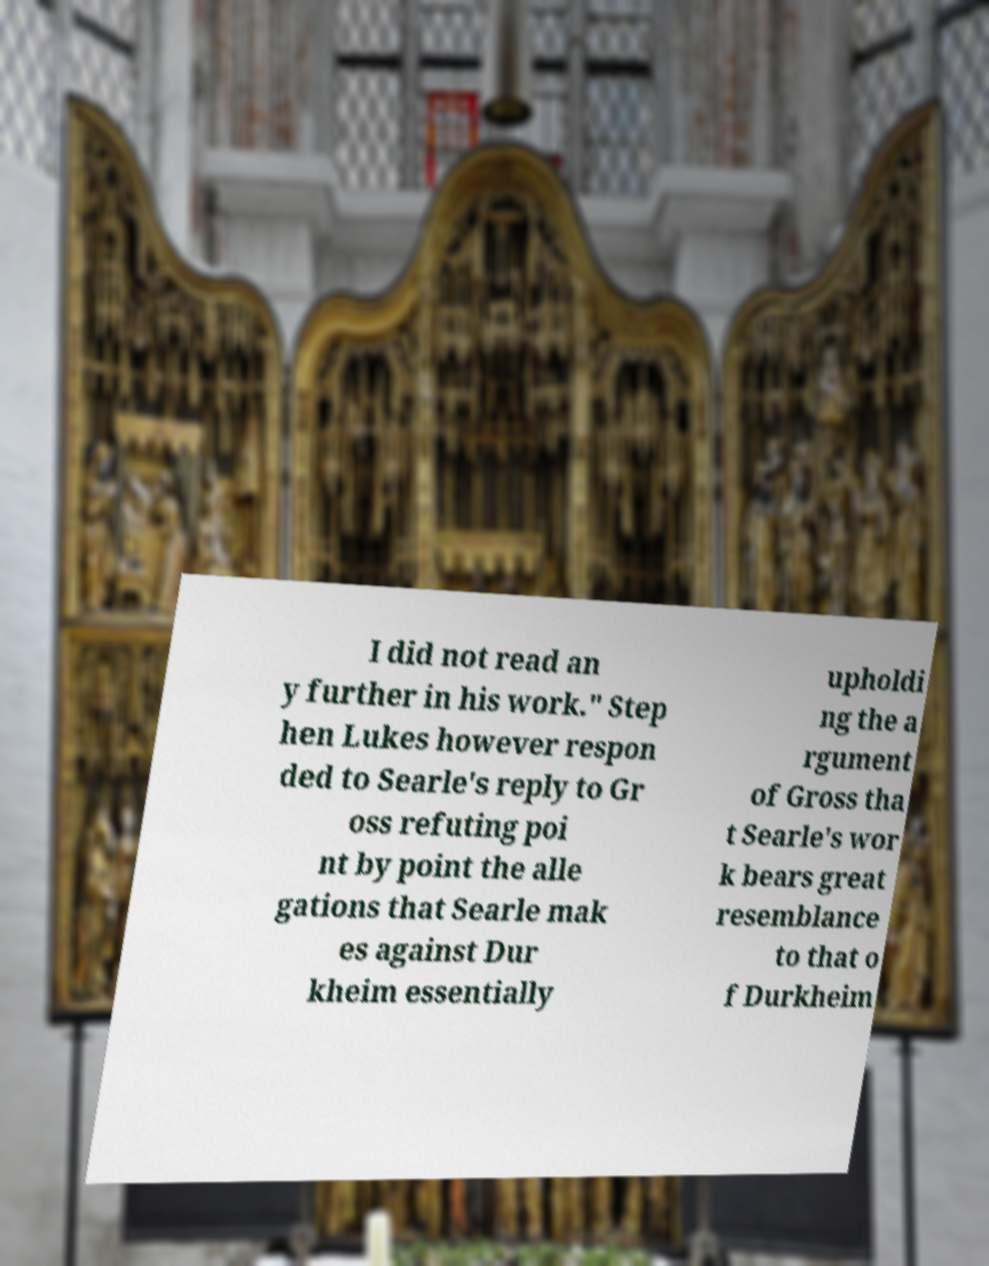Can you read and provide the text displayed in the image?This photo seems to have some interesting text. Can you extract and type it out for me? I did not read an y further in his work." Step hen Lukes however respon ded to Searle's reply to Gr oss refuting poi nt by point the alle gations that Searle mak es against Dur kheim essentially upholdi ng the a rgument of Gross tha t Searle's wor k bears great resemblance to that o f Durkheim 